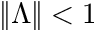Convert formula to latex. <formula><loc_0><loc_0><loc_500><loc_500>\| \Lambda \| < 1</formula> 